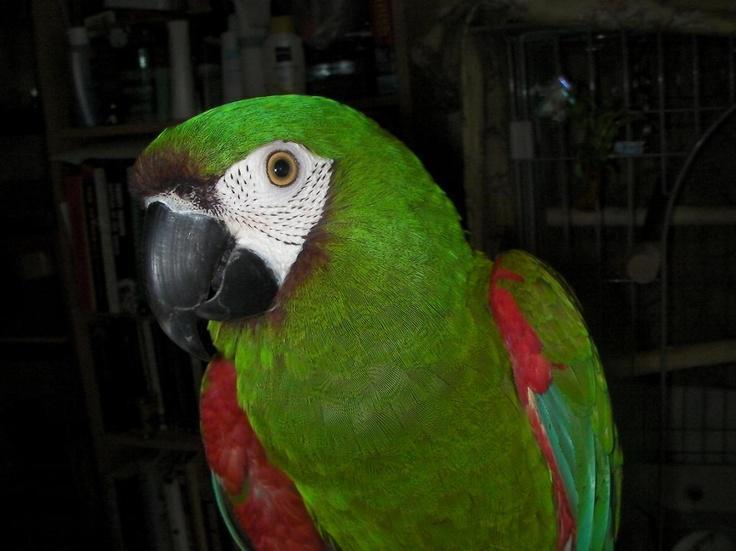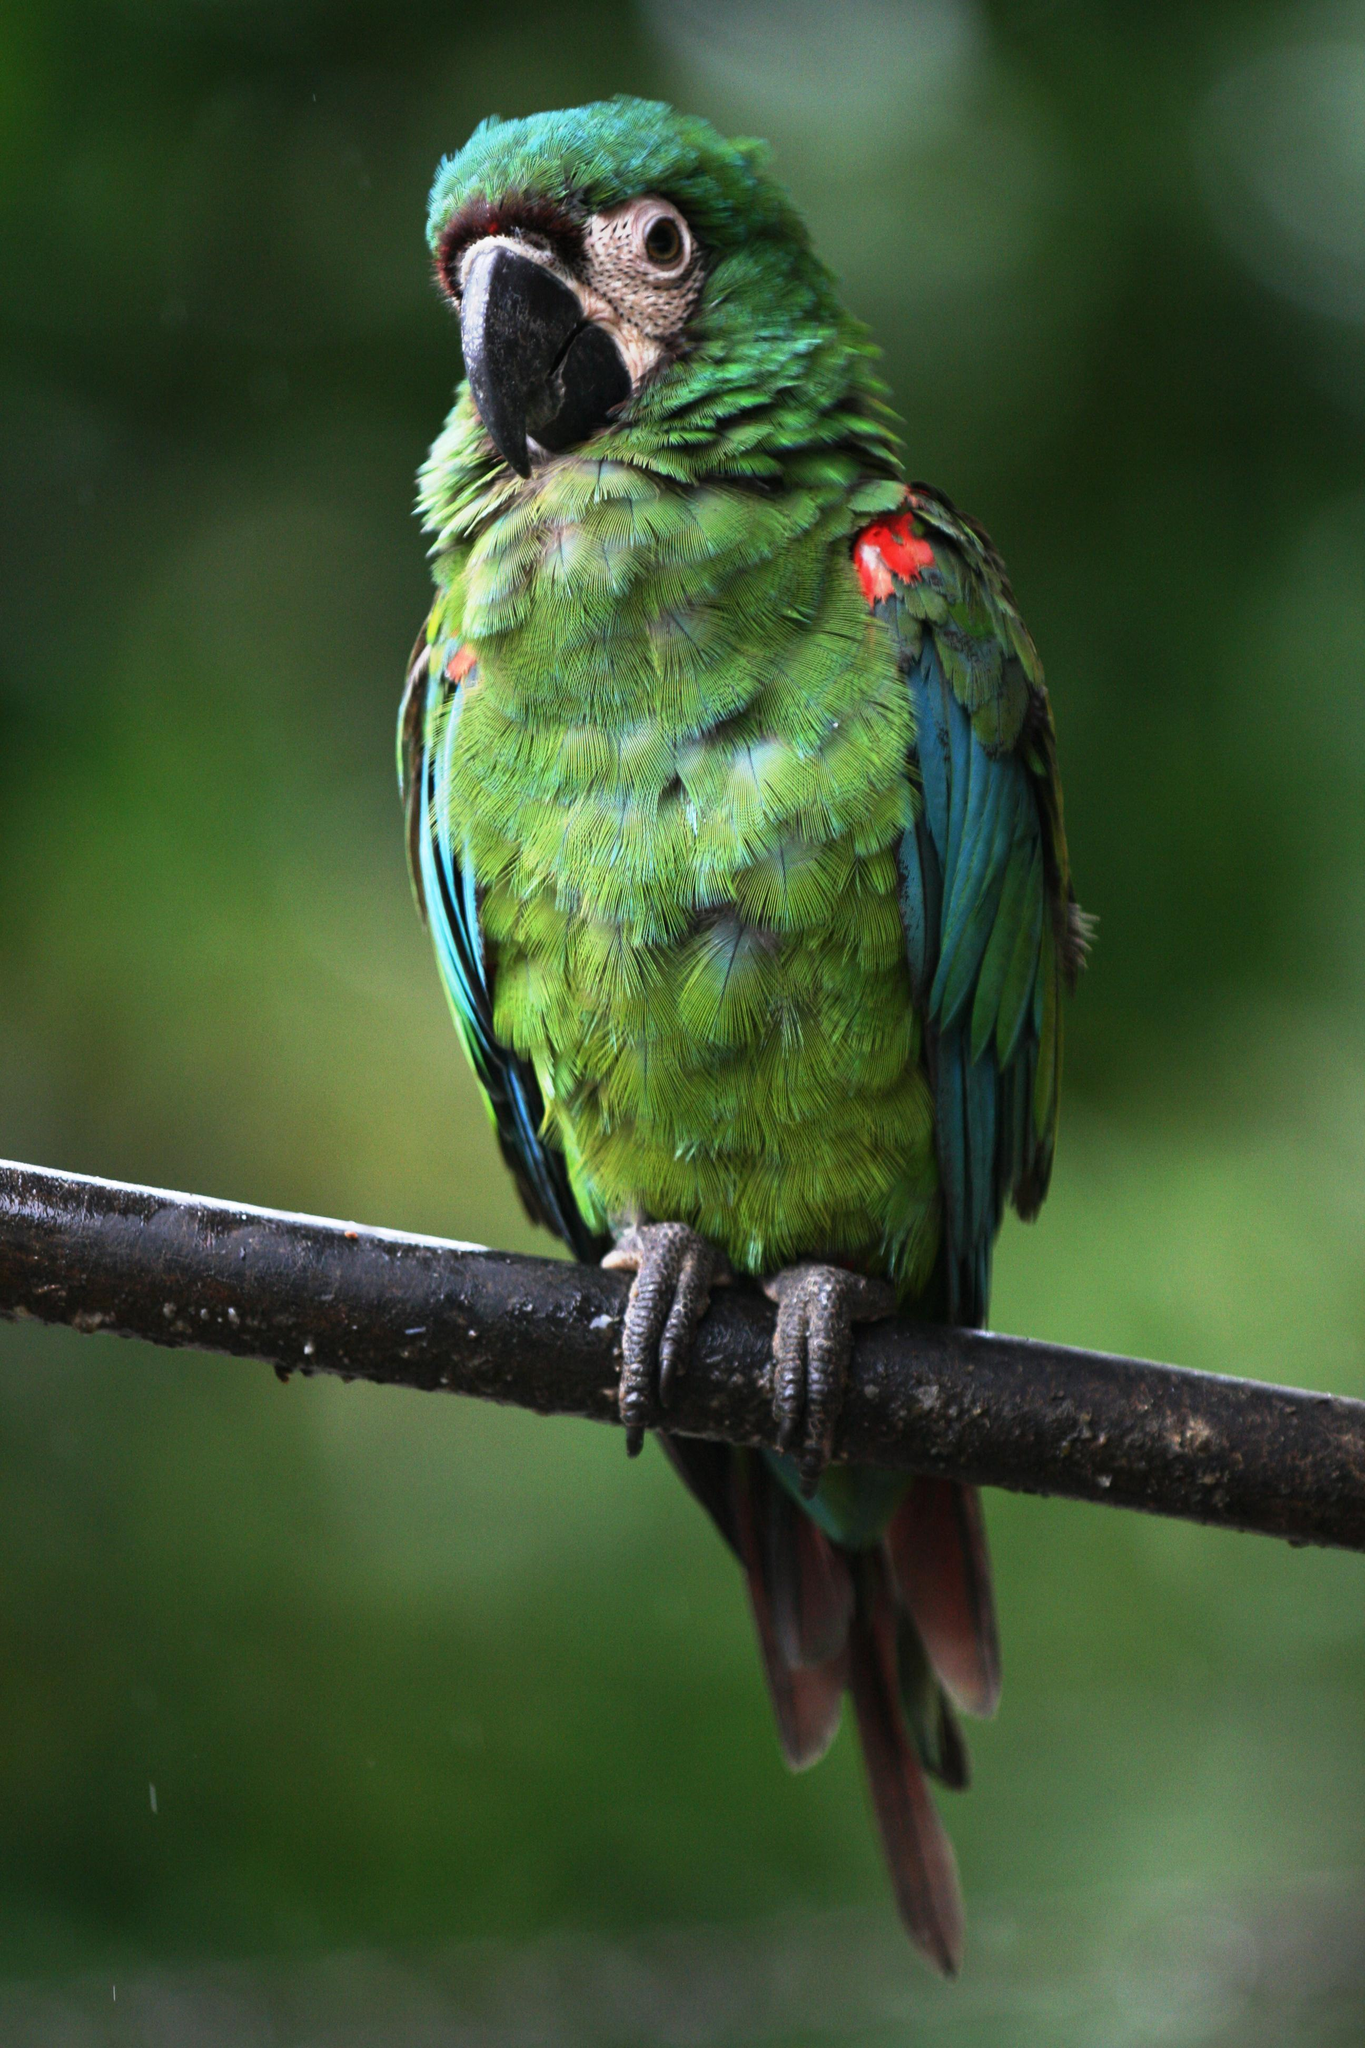The first image is the image on the left, the second image is the image on the right. Considering the images on both sides, is "In each image, the parrot faces rightward." valid? Answer yes or no. No. 